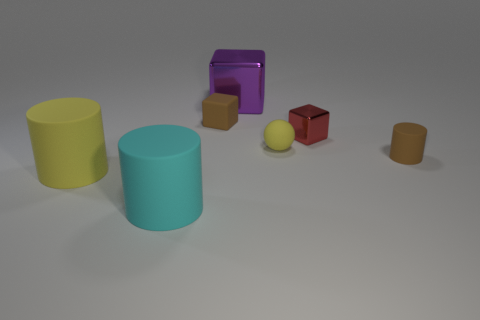Subtract all cyan blocks. Subtract all gray spheres. How many blocks are left? 3 Add 1 yellow objects. How many objects exist? 8 Subtract all blocks. How many objects are left? 4 Subtract all cyan rubber objects. Subtract all large shiny things. How many objects are left? 5 Add 7 large purple shiny cubes. How many large purple shiny cubes are left? 8 Add 6 big blue rubber spheres. How many big blue rubber spheres exist? 6 Subtract 1 purple blocks. How many objects are left? 6 